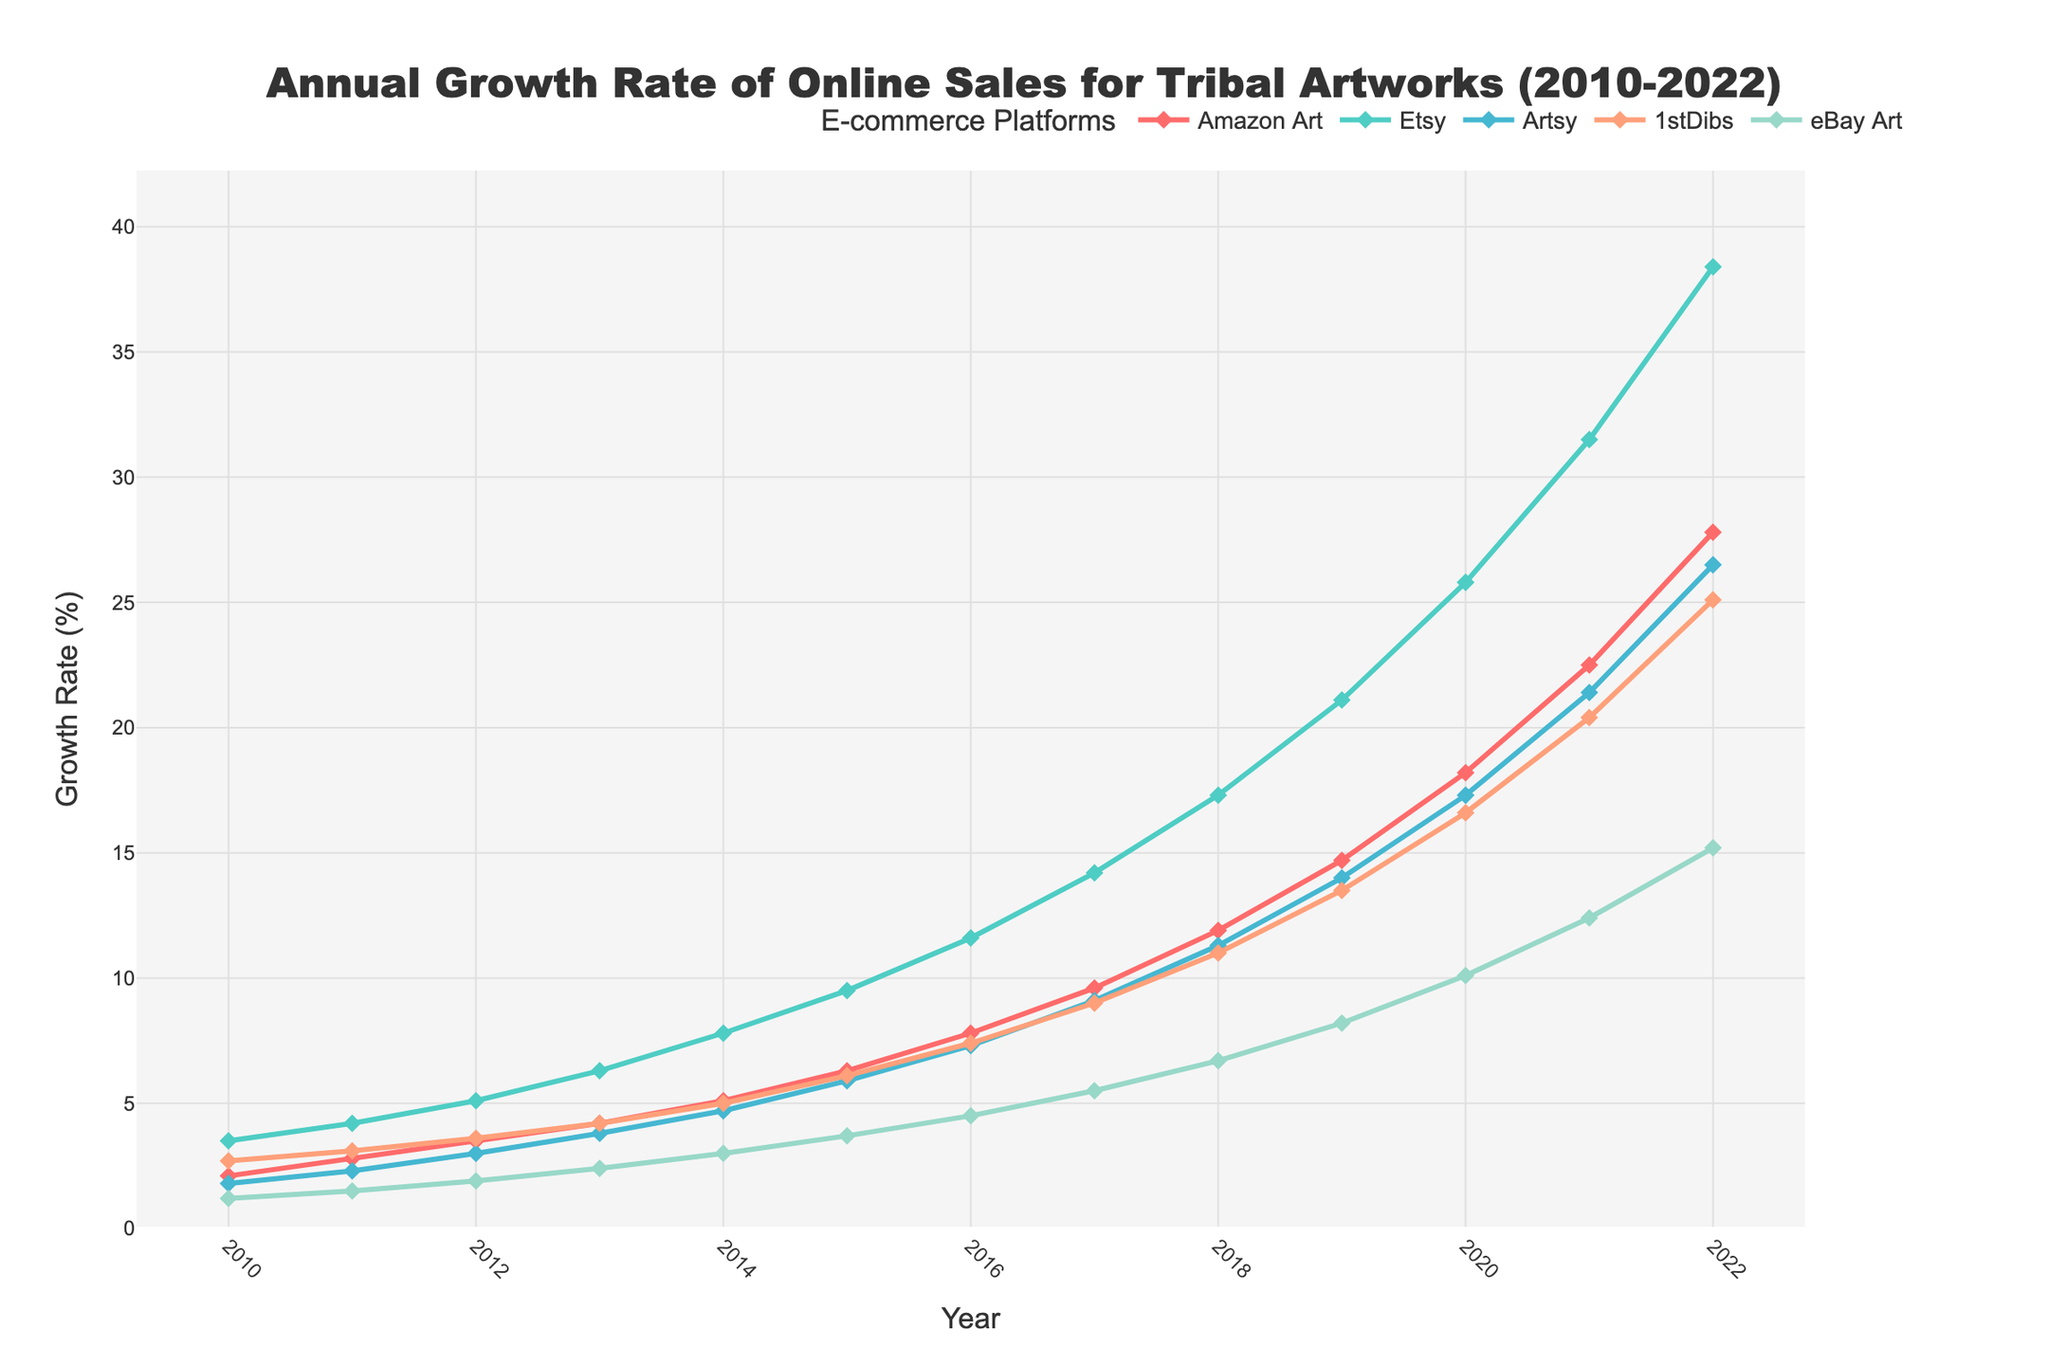Which platform had the highest annual growth rate in 2022? Find the highest point on the chart for the year 2022 and note the corresponding platform.
Answer: Etsy How has the growth rate for eBay Art changed from 2010 to 2022? Compare the growth rate values for eBay Art in 2010 and 2022. Specifically, look at the starting point in 2010 (1.2) and the endpoint in 2022 (15.2).
Answer: It increased by 14.0 Which platform showed the fastest growth between 2010 and 2022? Identify the platform with the steepest rise on the line chart from 2010 to 2022.
Answer: Etsy How did the growth rate of Amazon Art in 2015 compare to Art.sy in 2015? Locate the points for Amazon Art and Art.sy in 2015 and compare their growth rates (6.3 for Amazon Art and 5.9 for Art.sy).
Answer: Amazon Art was higher On which platforms did the growth rate double from 2016 to 2022? Check the growth rates in 2016 and 2022 for each platform and see if any values approximately doubled.
Answer: All platforms (Amazon Art, Etsy, Art.sy, 1stDibs, eBay Art) Which year showed the largest increase in growth rate for 1stDibs? Identify the year with the most significant rise by examining the difference in growth rates for each subsequent year specifically for 1stDibs.
Answer: 2020 Compare the growth rate of Etsy and Amazon Art in 2020. Which one was higher? Locate the values for Etsy and Amazon Art in 2020 (Etsy: 25.8, Amazon Art: 18.2) and compare them.
Answer: Etsy was higher What was the trend for Art.sy from 2010 to 2022? Examine the values for Art.sy from 2010 to 2022 and describe whether they generally increased, decreased, or remained stable.
Answer: Increasing trend How much did the growth rate for Etsy increase from 2012 to 2013? Take the values for Etsy in 2012 and 2013 and calculate the difference (6.3 - 5.1).
Answer: Increase by 1.2 Which platform had the lowest growth rate in 2010 and what was it? Locate the values for all platforms in 2010 and identify the lowest one, which is eBay Art at 1.2.
Answer: eBay Art, 1.2 